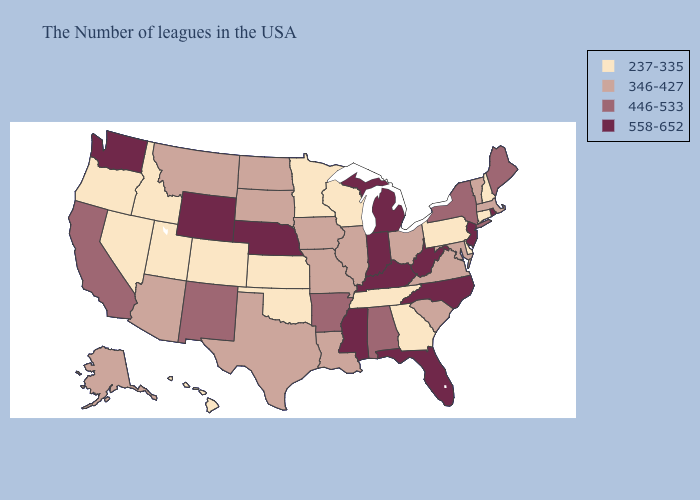Does the first symbol in the legend represent the smallest category?
Short answer required. Yes. Does Idaho have a higher value than Texas?
Quick response, please. No. Does the first symbol in the legend represent the smallest category?
Keep it brief. Yes. Does Nebraska have the lowest value in the MidWest?
Write a very short answer. No. Is the legend a continuous bar?
Quick response, please. No. What is the value of Montana?
Answer briefly. 346-427. What is the value of Iowa?
Concise answer only. 346-427. Does Arizona have a lower value than Florida?
Concise answer only. Yes. Name the states that have a value in the range 237-335?
Quick response, please. New Hampshire, Connecticut, Delaware, Pennsylvania, Georgia, Tennessee, Wisconsin, Minnesota, Kansas, Oklahoma, Colorado, Utah, Idaho, Nevada, Oregon, Hawaii. What is the value of New Jersey?
Give a very brief answer. 558-652. Among the states that border Arizona , which have the highest value?
Concise answer only. New Mexico, California. Does the first symbol in the legend represent the smallest category?
Keep it brief. Yes. Name the states that have a value in the range 558-652?
Keep it brief. Rhode Island, New Jersey, North Carolina, West Virginia, Florida, Michigan, Kentucky, Indiana, Mississippi, Nebraska, Wyoming, Washington. Which states have the lowest value in the West?
Be succinct. Colorado, Utah, Idaho, Nevada, Oregon, Hawaii. What is the highest value in the MidWest ?
Write a very short answer. 558-652. 